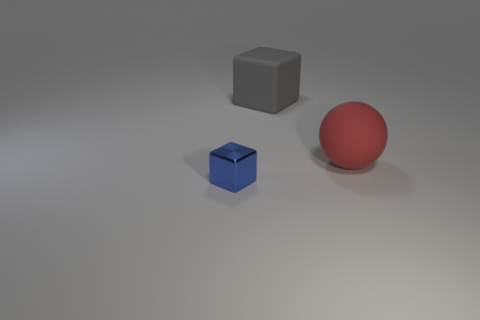Is the number of cubes less than the number of large spheres?
Offer a very short reply. No. There is a small metal object; are there any small objects on the left side of it?
Ensure brevity in your answer.  No. What is the shape of the object that is behind the shiny thing and to the left of the matte ball?
Provide a short and direct response. Cube. Are there any big gray matte things that have the same shape as the small blue shiny thing?
Your answer should be compact. Yes. Is the size of the block to the right of the small block the same as the cube to the left of the big gray thing?
Provide a succinct answer. No. Is the number of green balls greater than the number of rubber things?
Your answer should be very brief. No. How many big red balls are the same material as the small cube?
Offer a terse response. 0. Does the metallic object have the same shape as the big red object?
Keep it short and to the point. No. What size is the matte thing that is in front of the rubber object that is to the left of the rubber object that is right of the large gray object?
Offer a very short reply. Large. Are there any tiny blue metallic objects on the right side of the cube that is behind the small blue shiny cube?
Your response must be concise. No. 